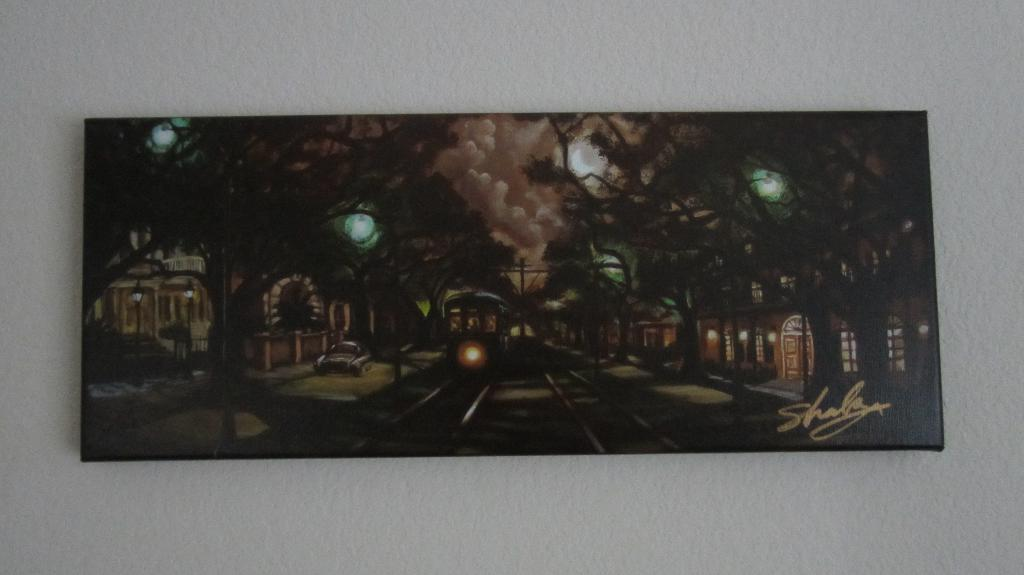<image>
Offer a succinct explanation of the picture presented. Painting showing a dark night and a signature that says Shala. 